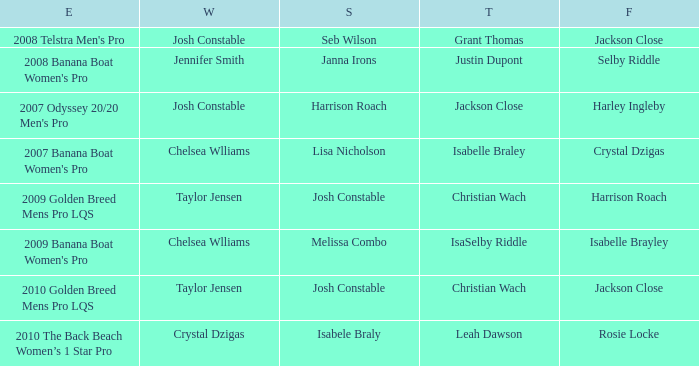Who was Fourth in the 2008 Telstra Men's Pro Event? Jackson Close. 